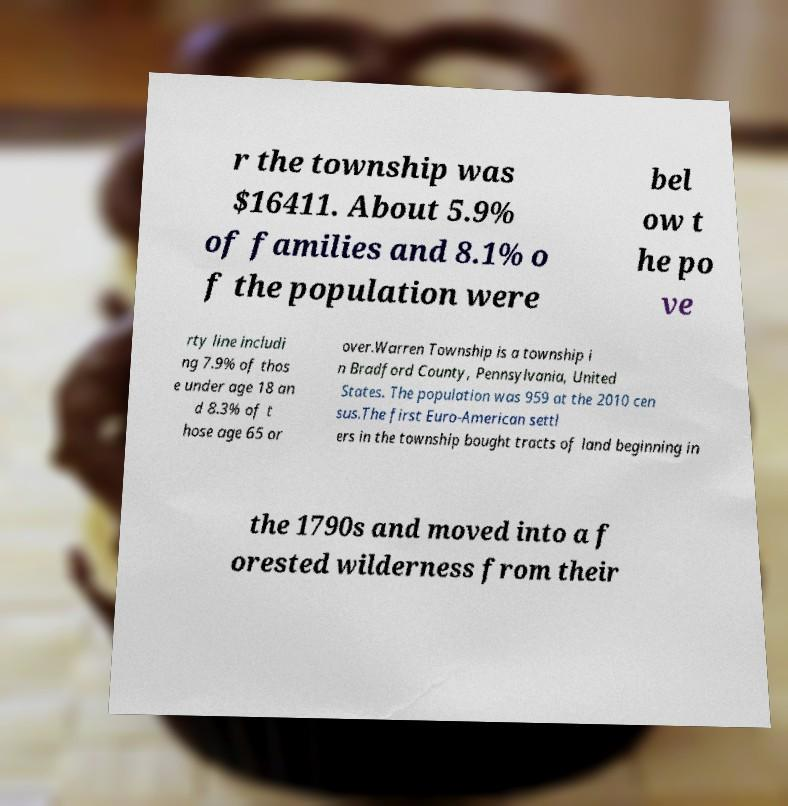I need the written content from this picture converted into text. Can you do that? r the township was $16411. About 5.9% of families and 8.1% o f the population were bel ow t he po ve rty line includi ng 7.9% of thos e under age 18 an d 8.3% of t hose age 65 or over.Warren Township is a township i n Bradford County, Pennsylvania, United States. The population was 959 at the 2010 cen sus.The first Euro-American settl ers in the township bought tracts of land beginning in the 1790s and moved into a f orested wilderness from their 